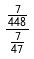Convert formula to latex. <formula><loc_0><loc_0><loc_500><loc_500>\frac { \frac { 7 } { 4 4 8 } } { \frac { 7 } { 4 7 } }</formula> 